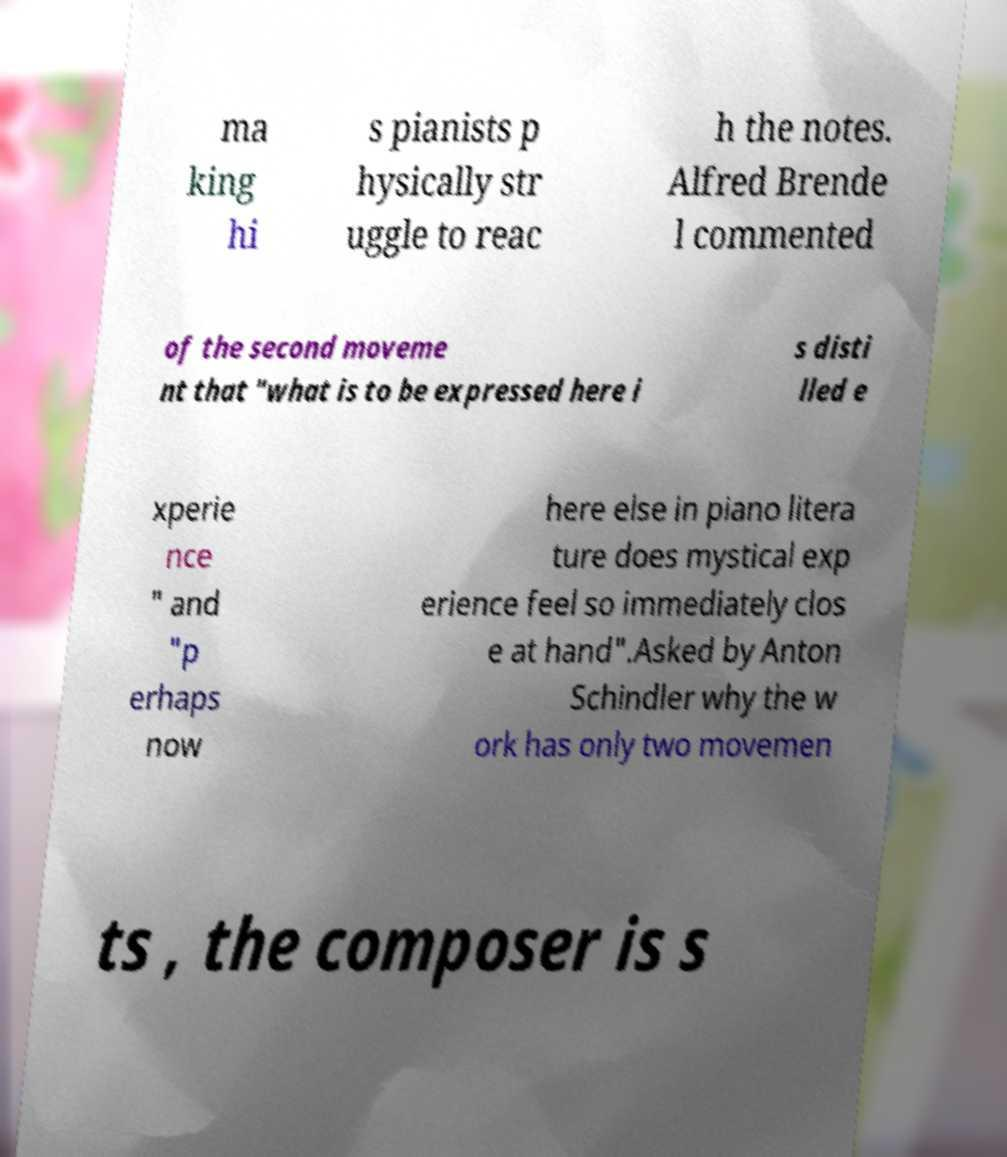Could you assist in decoding the text presented in this image and type it out clearly? ma king hi s pianists p hysically str uggle to reac h the notes. Alfred Brende l commented of the second moveme nt that "what is to be expressed here i s disti lled e xperie nce " and "p erhaps now here else in piano litera ture does mystical exp erience feel so immediately clos e at hand".Asked by Anton Schindler why the w ork has only two movemen ts , the composer is s 